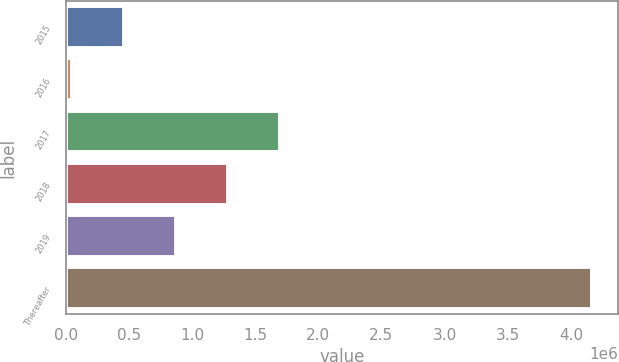Convert chart. <chart><loc_0><loc_0><loc_500><loc_500><bar_chart><fcel>2015<fcel>2016<fcel>2017<fcel>2018<fcel>2019<fcel>Thereafter<nl><fcel>464679<fcel>53353<fcel>1.69866e+06<fcel>1.28733e+06<fcel>876004<fcel>4.16661e+06<nl></chart> 